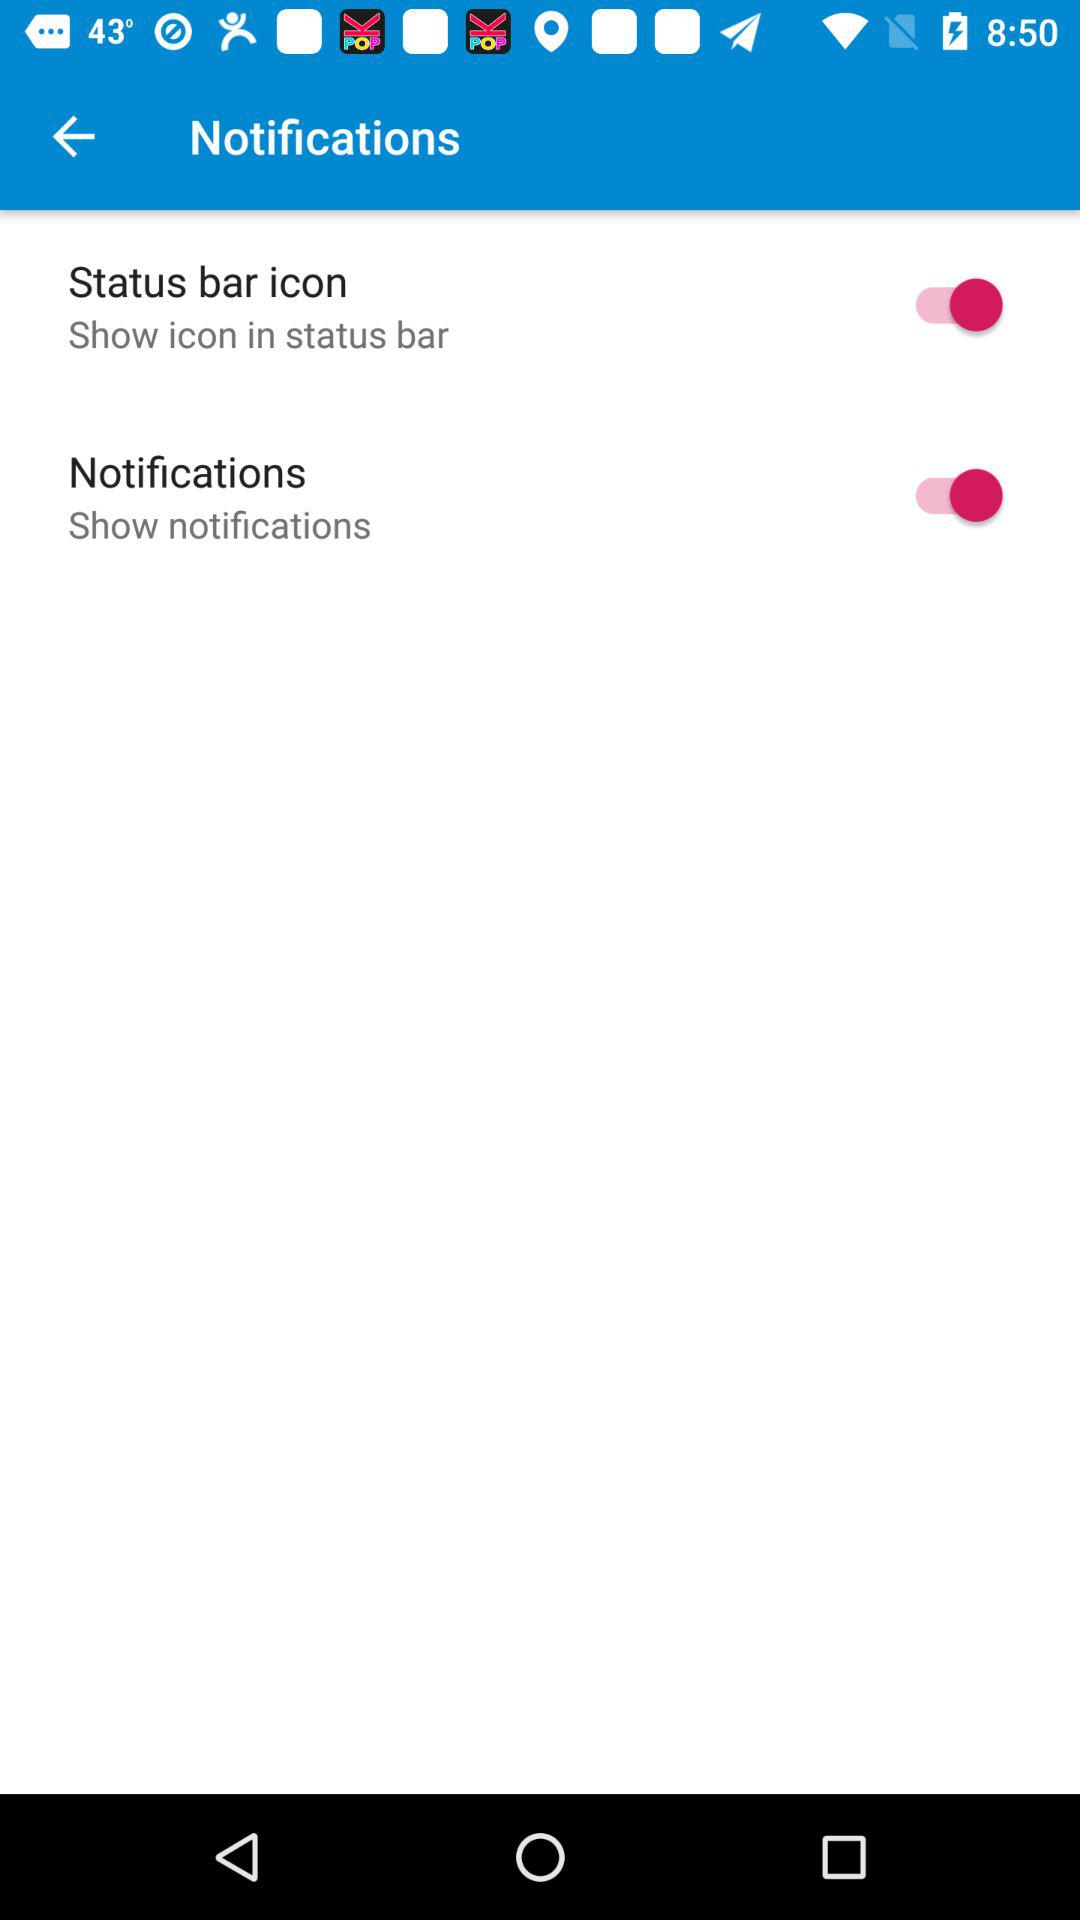What is the status of "Status bar icon"? The status is "on". 